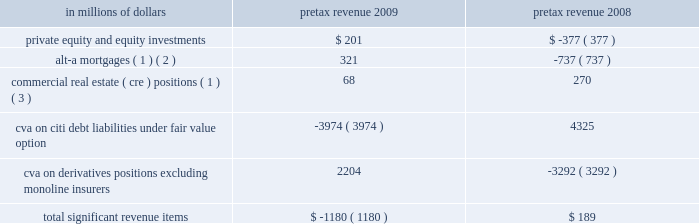2009 vs .
2008 revenues , net of interest expense increased 11% ( 11 % ) or $ 2.7 billion , as markets began to recover in the early part of 2009 , bringing back higher levels of volume activity and higher levels of liquidity , which began to decline again in the third quarter of 2009 .
The growth in revenue in the early part of the year was mainly due to a $ 7.1 billion increase in fixed income markets , reflecting strong trading opportunities across all asset classes in the first half of 2009 , and a $ 1.5 billion increase in investment banking revenue primarily from increases in debt and equity underwriting activities reflecting higher transaction volumes from depressed 2008 levels .
These increases were offset by a $ 6.4 billion decrease in lending revenue primarily from losses on credit default swap hedges .
Excluding the 2009 and 2008 cva impact , as indicated in the table below , revenues increased 23% ( 23 % ) or $ 5.5 billion .
Operating expenses decreased 17% ( 17 % ) , or $ 2.7 billion .
Excluding the 2008 repositioning and restructuring charges and the 2009 litigation reserve release , operating expenses declined 11% ( 11 % ) or $ 1.6 billion , mainly as a result of headcount reductions and benefits from expense management .
Provisions for loan losses and for benefits and claims decreased 7% ( 7 % ) or $ 129 million , to $ 1.7 billion , mainly due to lower credit reserve builds and net credit losses , due to an improved credit environment , particularly in the latter part of the year .
2008 vs .
2007 revenues , net of interest expense decreased 2% ( 2 % ) or $ 0.4 billion reflecting the overall difficult market conditions .
Excluding the 2008 and 2007 cva impact , revenues decreased 3% ( 3 % ) or $ 0.6 billion .
The reduction in revenue was primarily due to a decrease in investment banking revenue of $ 2.3 billion to $ 3.2 billion , mainly in debt and equity underwriting , reflecting lower volumes , and a decrease in equity markets revenue of $ 2.3 billion to $ 2.9 billion due to extremely high volatility and reduced levels of activity .
These reductions were offset by an increase in fixed income markets of $ 2.9 billion to $ 14.4 billion due to strong performance in interest rates and currencies , and an increase in lending revenue of $ 2.4 billion to $ 4.2 billion mainly from gains on credit default swap hedges .
Operating expenses decreased by 2% ( 2 % ) or $ 0.4 billion .
Excluding the 2008 and 2007 repositioning and restructuring charges and the 2007 litigation reserve reversal , operating expenses decreased by 7% ( 7 % ) or $ 1.1 billion driven by headcount reduction and lower performance-based incentives .
Provisions for credit losses and for benefits and claims increased $ 1.3 billion to $ 1.8 billion mainly from higher credit reserve builds and net credit losses offset by a lower provision for unfunded lending commitments due to deterioration in the credit environment .
Certain revenues impacting securities and banking items that impacted s&b revenues during 2009 and 2008 are set forth in the table below. .
( 1 ) net of hedges .
( 2 ) for these purposes , alt-a mortgage securities are non-agency residential mortgage-backed securities ( rmbs ) where ( i ) the underlying collateral has weighted average fico scores between 680 and 720 or ( ii ) for instances where fico scores are greater than 720 , rmbs have 30% ( 30 % ) or less of the underlying collateral composed of full documentation loans .
See 201cmanaging global risk 2014credit risk 2014u.s .
Consumer mortgage lending . 201d ( 3 ) s&b 2019s commercial real estate exposure is split into three categories of assets : held at fair value ; held- to-maturity/held-for-investment ; and equity .
See 201cmanaging global risk 2014credit risk 2014exposure to commercial real estate 201d section for a further discussion .
In the table above , 2009 includes a $ 330 million pretax adjustment to the cva balance , which reduced pretax revenues for the year , reflecting a correction of an error related to prior periods .
See 201csignificant accounting policies and significant estimates 201d below and notes 1 and 34 to the consolidated financial statements for a further discussion of this adjustment .
2010 outlook the 2010 outlook for s&b will depend on the level of client activity and on macroeconomic conditions , market valuations and volatility , interest rates and other market factors .
Management of s&b currently expects to maintain client activity throughout 2010 and to operate in market conditions that offer moderate volatility and increased liquidity .
Operating expenses will benefit from continued re-engineering and expense management initiatives , but will be offset by investments in talent and infrastructure to support growth. .
What was the change in millions of private equity and equity investments pretax revenue from 2008 to 2009? 
Computations: (201 - -377)
Answer: 578.0. 2009 vs .
2008 revenues , net of interest expense increased 11% ( 11 % ) or $ 2.7 billion , as markets began to recover in the early part of 2009 , bringing back higher levels of volume activity and higher levels of liquidity , which began to decline again in the third quarter of 2009 .
The growth in revenue in the early part of the year was mainly due to a $ 7.1 billion increase in fixed income markets , reflecting strong trading opportunities across all asset classes in the first half of 2009 , and a $ 1.5 billion increase in investment banking revenue primarily from increases in debt and equity underwriting activities reflecting higher transaction volumes from depressed 2008 levels .
These increases were offset by a $ 6.4 billion decrease in lending revenue primarily from losses on credit default swap hedges .
Excluding the 2009 and 2008 cva impact , as indicated in the table below , revenues increased 23% ( 23 % ) or $ 5.5 billion .
Operating expenses decreased 17% ( 17 % ) , or $ 2.7 billion .
Excluding the 2008 repositioning and restructuring charges and the 2009 litigation reserve release , operating expenses declined 11% ( 11 % ) or $ 1.6 billion , mainly as a result of headcount reductions and benefits from expense management .
Provisions for loan losses and for benefits and claims decreased 7% ( 7 % ) or $ 129 million , to $ 1.7 billion , mainly due to lower credit reserve builds and net credit losses , due to an improved credit environment , particularly in the latter part of the year .
2008 vs .
2007 revenues , net of interest expense decreased 2% ( 2 % ) or $ 0.4 billion reflecting the overall difficult market conditions .
Excluding the 2008 and 2007 cva impact , revenues decreased 3% ( 3 % ) or $ 0.6 billion .
The reduction in revenue was primarily due to a decrease in investment banking revenue of $ 2.3 billion to $ 3.2 billion , mainly in debt and equity underwriting , reflecting lower volumes , and a decrease in equity markets revenue of $ 2.3 billion to $ 2.9 billion due to extremely high volatility and reduced levels of activity .
These reductions were offset by an increase in fixed income markets of $ 2.9 billion to $ 14.4 billion due to strong performance in interest rates and currencies , and an increase in lending revenue of $ 2.4 billion to $ 4.2 billion mainly from gains on credit default swap hedges .
Operating expenses decreased by 2% ( 2 % ) or $ 0.4 billion .
Excluding the 2008 and 2007 repositioning and restructuring charges and the 2007 litigation reserve reversal , operating expenses decreased by 7% ( 7 % ) or $ 1.1 billion driven by headcount reduction and lower performance-based incentives .
Provisions for credit losses and for benefits and claims increased $ 1.3 billion to $ 1.8 billion mainly from higher credit reserve builds and net credit losses offset by a lower provision for unfunded lending commitments due to deterioration in the credit environment .
Certain revenues impacting securities and banking items that impacted s&b revenues during 2009 and 2008 are set forth in the table below. .
( 1 ) net of hedges .
( 2 ) for these purposes , alt-a mortgage securities are non-agency residential mortgage-backed securities ( rmbs ) where ( i ) the underlying collateral has weighted average fico scores between 680 and 720 or ( ii ) for instances where fico scores are greater than 720 , rmbs have 30% ( 30 % ) or less of the underlying collateral composed of full documentation loans .
See 201cmanaging global risk 2014credit risk 2014u.s .
Consumer mortgage lending . 201d ( 3 ) s&b 2019s commercial real estate exposure is split into three categories of assets : held at fair value ; held- to-maturity/held-for-investment ; and equity .
See 201cmanaging global risk 2014credit risk 2014exposure to commercial real estate 201d section for a further discussion .
In the table above , 2009 includes a $ 330 million pretax adjustment to the cva balance , which reduced pretax revenues for the year , reflecting a correction of an error related to prior periods .
See 201csignificant accounting policies and significant estimates 201d below and notes 1 and 34 to the consolidated financial statements for a further discussion of this adjustment .
2010 outlook the 2010 outlook for s&b will depend on the level of client activity and on macroeconomic conditions , market valuations and volatility , interest rates and other market factors .
Management of s&b currently expects to maintain client activity throughout 2010 and to operate in market conditions that offer moderate volatility and increased liquidity .
Operating expenses will benefit from continued re-engineering and expense management initiatives , but will be offset by investments in talent and infrastructure to support growth. .
What was the net change in the private equity and equity investments from 2008 to 2009 in millions? 
Rationale: the private equity and equity investments increased by 578 million from 2008 to 2009
Computations: (201 - -377)
Answer: 578.0. 